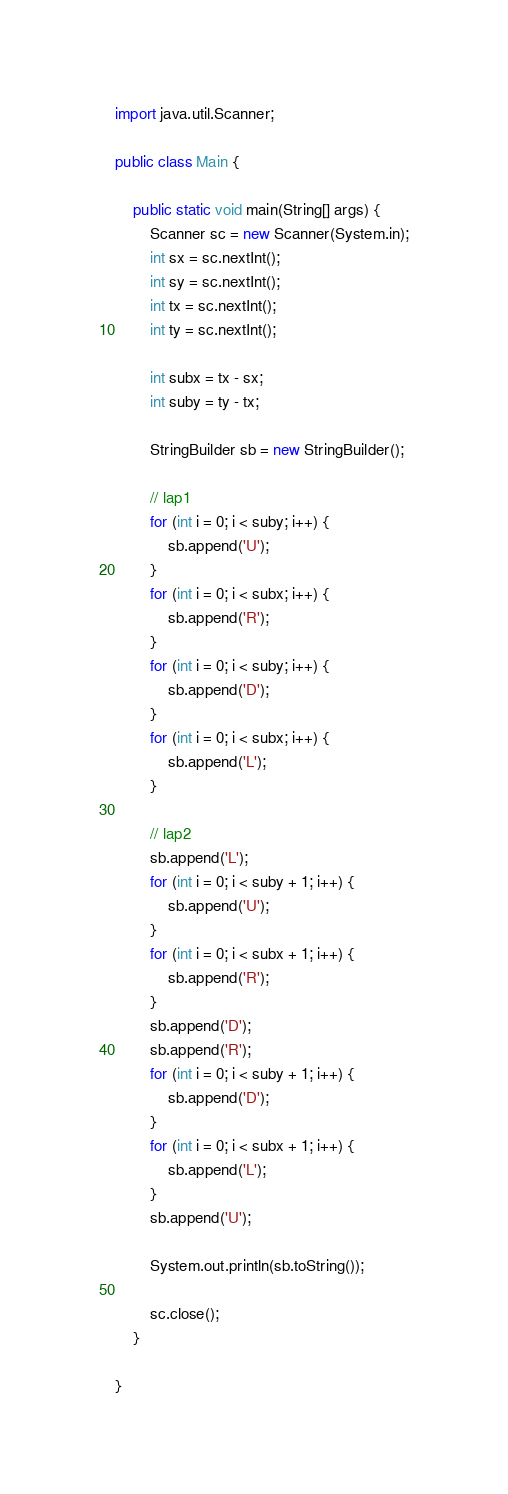Convert code to text. <code><loc_0><loc_0><loc_500><loc_500><_Java_>import java.util.Scanner;

public class Main {

	public static void main(String[] args) {
		Scanner sc = new Scanner(System.in);
		int sx = sc.nextInt();
		int sy = sc.nextInt();
		int tx = sc.nextInt();
		int ty = sc.nextInt();

		int subx = tx - sx;
		int suby = ty - tx;

		StringBuilder sb = new StringBuilder();

		// lap1
		for (int i = 0; i < suby; i++) {
			sb.append('U');
		}
		for (int i = 0; i < subx; i++) {
			sb.append('R');
		}
		for (int i = 0; i < suby; i++) {
			sb.append('D');
		}
		for (int i = 0; i < subx; i++) {
			sb.append('L');
		}

		// lap2
		sb.append('L');
		for (int i = 0; i < suby + 1; i++) {
			sb.append('U');
		}
		for (int i = 0; i < subx + 1; i++) {
			sb.append('R');
		}
		sb.append('D');
		sb.append('R');
		for (int i = 0; i < suby + 1; i++) {
			sb.append('D');
		}
		for (int i = 0; i < subx + 1; i++) {
			sb.append('L');
		}
		sb.append('U');

		System.out.println(sb.toString());

		sc.close();
	}

}
</code> 